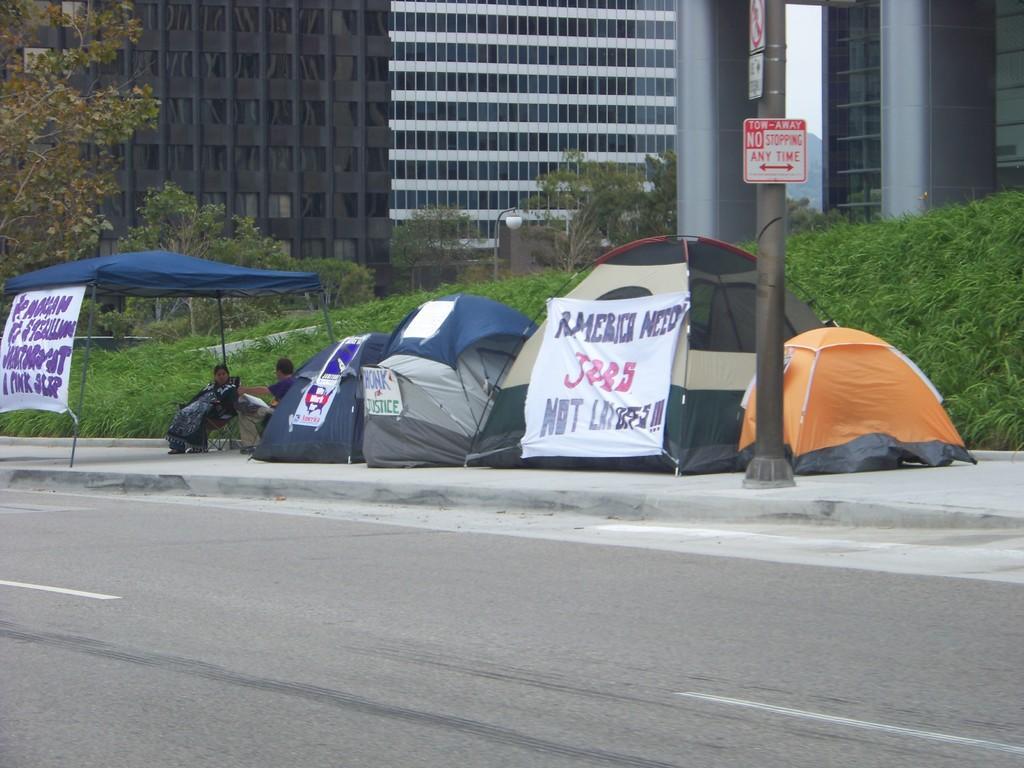How would you summarize this image in a sentence or two? In this picture I can see there are few tents on the walk way and there are few people sitting here and there are few banners and there are few poles. In the backdrop there's grass on to right and there are few buildings here and they have glass windows. 